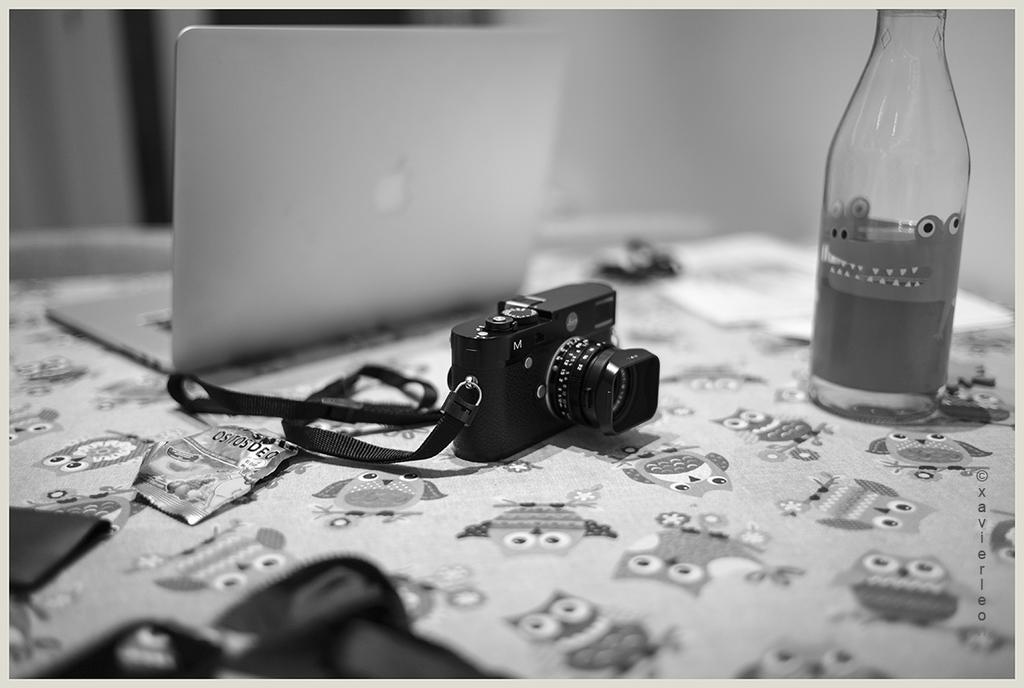What device is visible in the image? There is a camera in the image. Where is the camera located? The camera is placed on a table. What other electronic device can be seen in the image? There is a laptop in the image. Where is the laptop placed? The laptop is also placed on a table. What additional object is present on the table? There is a bottle in the image. What type of harmony is being played on the table in the image? There is no musical instrument or harmony present in the image; it features a camera, laptop, and bottle on a table. 